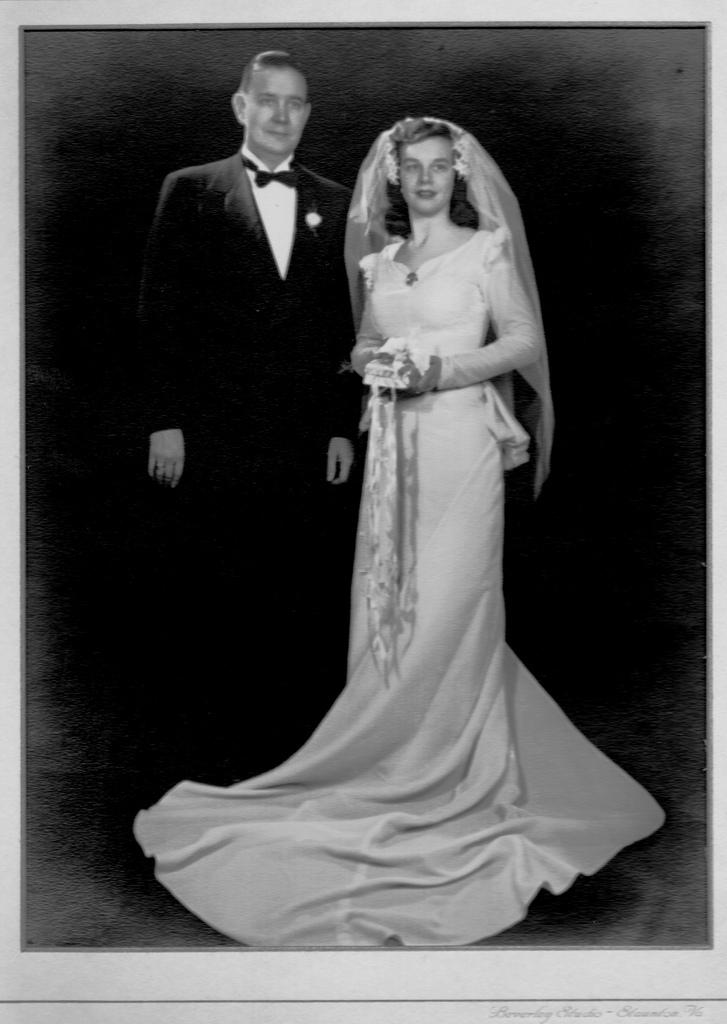What type of image is shown? The image is a photograph. What color scheme is used in the image? The image is black and white. How many people are in the image? There is a man and a woman in the image. What are the man and woman doing in the image? The man and woman are standing on the floor. What expressions do the man and woman have in the image? The man and woman have smiling faces. What type of sign is the man holding in the image? There is no sign present in the image. 